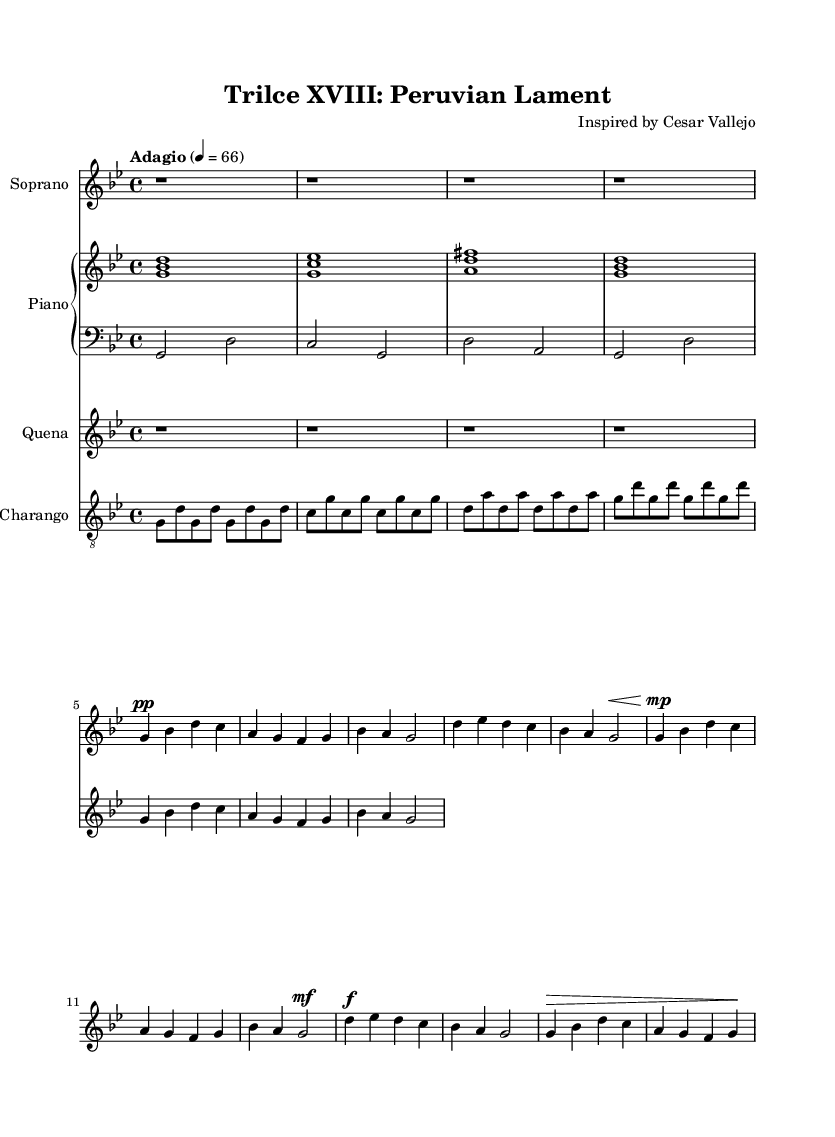What is the key signature of this music? The key signature is G minor, which has two flats (B flat and E flat). This can be identified by examining the key signature at the beginning of the staff, where the flats are indicated.
Answer: G minor What is the time signature? The time signature is 4/4, as shown at the start of the piece. This means there are four beats per measure, with the quarter note receiving one beat.
Answer: 4/4 What is the tempo marking for this piece? The tempo marking is Adagio, which indicates a slow tempo. It is specified at the beginning, stating the desired speed as quarter note equals 66.
Answer: Adagio How many measures are in the first verse? There are 8 measures in the first verse, which can be counted by looking at the measure bars present in the score, starting from the introduction to the end of the first verse.
Answer: 8 What dynamic marking is indicated for the chorus? The dynamic marking for the chorus is forte (f), which instructs the performer to play loudly. This is specified at the beginning of the chorus section in the vocal line.
Answer: forte Which instruments are featured in this composition? The featured instruments are soprano, piano, quena, and charango. Each instrument is listed as a separate staff in the score, clearly noting their roles.
Answer: Soprano, piano, quena, charango What type of opera is this piece inspired by? This piece is inspired by Peruvian-inspired opera, which uniquely reflects themes from Cesar Vallejo's poetry. This can be inferred from the title and the composer's note.
Answer: Peruvian-inspired opera 